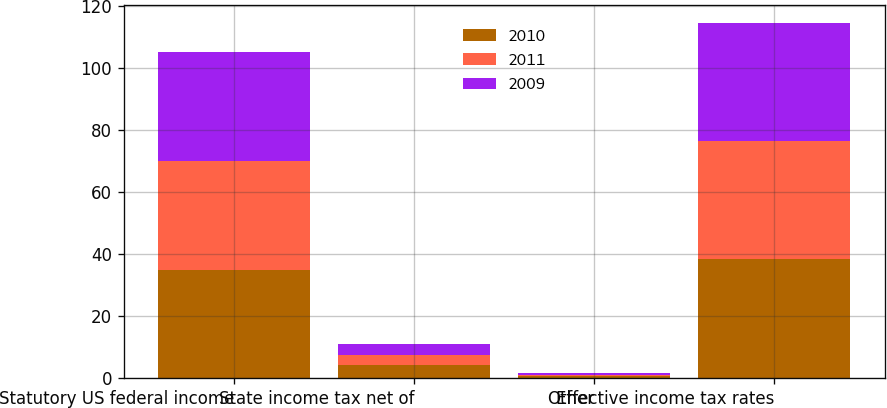Convert chart. <chart><loc_0><loc_0><loc_500><loc_500><stacked_bar_chart><ecel><fcel>Statutory US federal income<fcel>State income tax net of<fcel>Other<fcel>Effective income tax rates<nl><fcel>2010<fcel>35<fcel>4.1<fcel>0.6<fcel>38.5<nl><fcel>2011<fcel>35<fcel>3.5<fcel>0.4<fcel>38.1<nl><fcel>2009<fcel>35<fcel>3.4<fcel>0.5<fcel>37.9<nl></chart> 